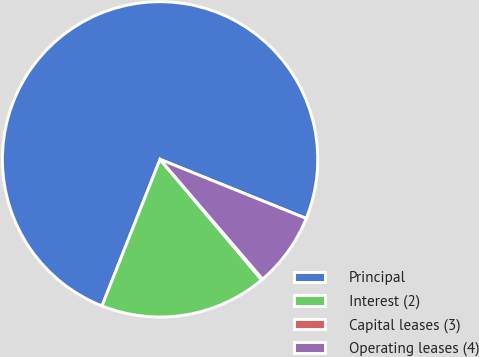Convert chart to OTSL. <chart><loc_0><loc_0><loc_500><loc_500><pie_chart><fcel>Principal<fcel>Interest (2)<fcel>Capital leases (3)<fcel>Operating leases (4)<nl><fcel>75.12%<fcel>17.15%<fcel>0.12%<fcel>7.62%<nl></chart> 